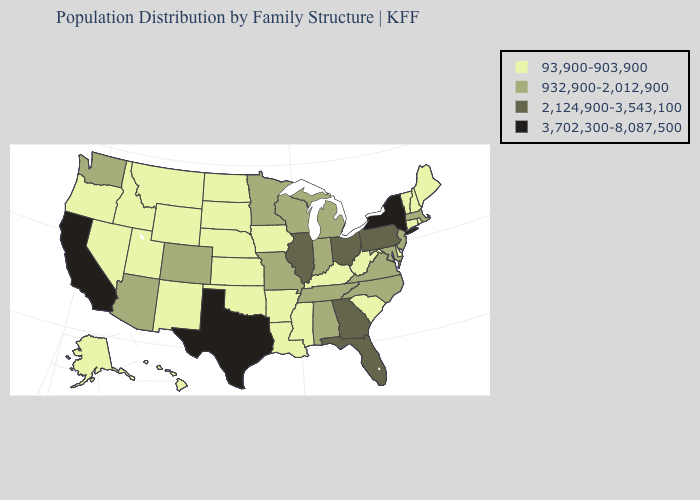Among the states that border New York , does Vermont have the lowest value?
Concise answer only. Yes. Which states have the lowest value in the USA?
Be succinct. Alaska, Arkansas, Connecticut, Delaware, Hawaii, Idaho, Iowa, Kansas, Kentucky, Louisiana, Maine, Mississippi, Montana, Nebraska, Nevada, New Hampshire, New Mexico, North Dakota, Oklahoma, Oregon, Rhode Island, South Carolina, South Dakota, Utah, Vermont, West Virginia, Wyoming. Which states have the lowest value in the USA?
Keep it brief. Alaska, Arkansas, Connecticut, Delaware, Hawaii, Idaho, Iowa, Kansas, Kentucky, Louisiana, Maine, Mississippi, Montana, Nebraska, Nevada, New Hampshire, New Mexico, North Dakota, Oklahoma, Oregon, Rhode Island, South Carolina, South Dakota, Utah, Vermont, West Virginia, Wyoming. Among the states that border Ohio , does Pennsylvania have the lowest value?
Answer briefly. No. What is the lowest value in the South?
Be succinct. 93,900-903,900. Name the states that have a value in the range 3,702,300-8,087,500?
Quick response, please. California, New York, Texas. Name the states that have a value in the range 3,702,300-8,087,500?
Quick response, please. California, New York, Texas. Which states hav the highest value in the Northeast?
Short answer required. New York. What is the highest value in the USA?
Answer briefly. 3,702,300-8,087,500. Which states have the lowest value in the USA?
Answer briefly. Alaska, Arkansas, Connecticut, Delaware, Hawaii, Idaho, Iowa, Kansas, Kentucky, Louisiana, Maine, Mississippi, Montana, Nebraska, Nevada, New Hampshire, New Mexico, North Dakota, Oklahoma, Oregon, Rhode Island, South Carolina, South Dakota, Utah, Vermont, West Virginia, Wyoming. Name the states that have a value in the range 93,900-903,900?
Write a very short answer. Alaska, Arkansas, Connecticut, Delaware, Hawaii, Idaho, Iowa, Kansas, Kentucky, Louisiana, Maine, Mississippi, Montana, Nebraska, Nevada, New Hampshire, New Mexico, North Dakota, Oklahoma, Oregon, Rhode Island, South Carolina, South Dakota, Utah, Vermont, West Virginia, Wyoming. What is the lowest value in the Northeast?
Quick response, please. 93,900-903,900. Which states have the highest value in the USA?
Give a very brief answer. California, New York, Texas. What is the value of Arkansas?
Concise answer only. 93,900-903,900. How many symbols are there in the legend?
Concise answer only. 4. 